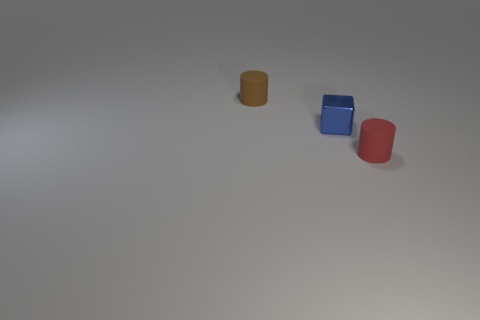There is a thing behind the blue metallic block; what shape is it?
Make the answer very short. Cylinder. Are there any red matte cylinders that have the same size as the blue object?
Your response must be concise. Yes. There is a brown thing that is the same size as the blue shiny thing; what is its material?
Make the answer very short. Rubber. What size is the matte cylinder that is on the left side of the red object?
Ensure brevity in your answer.  Small. How big is the red matte thing?
Make the answer very short. Small. Does the red rubber thing have the same size as the matte object that is to the left of the tiny blue metal block?
Keep it short and to the point. Yes. What is the color of the small matte object on the right side of the rubber object that is left of the tiny red matte thing?
Offer a terse response. Red. Are there an equal number of tiny blue things that are on the left side of the small cube and red cylinders that are on the right side of the red matte object?
Offer a terse response. Yes. Is the tiny cube in front of the tiny brown thing made of the same material as the brown object?
Ensure brevity in your answer.  No. The object that is in front of the brown thing and behind the red rubber object is what color?
Ensure brevity in your answer.  Blue. 